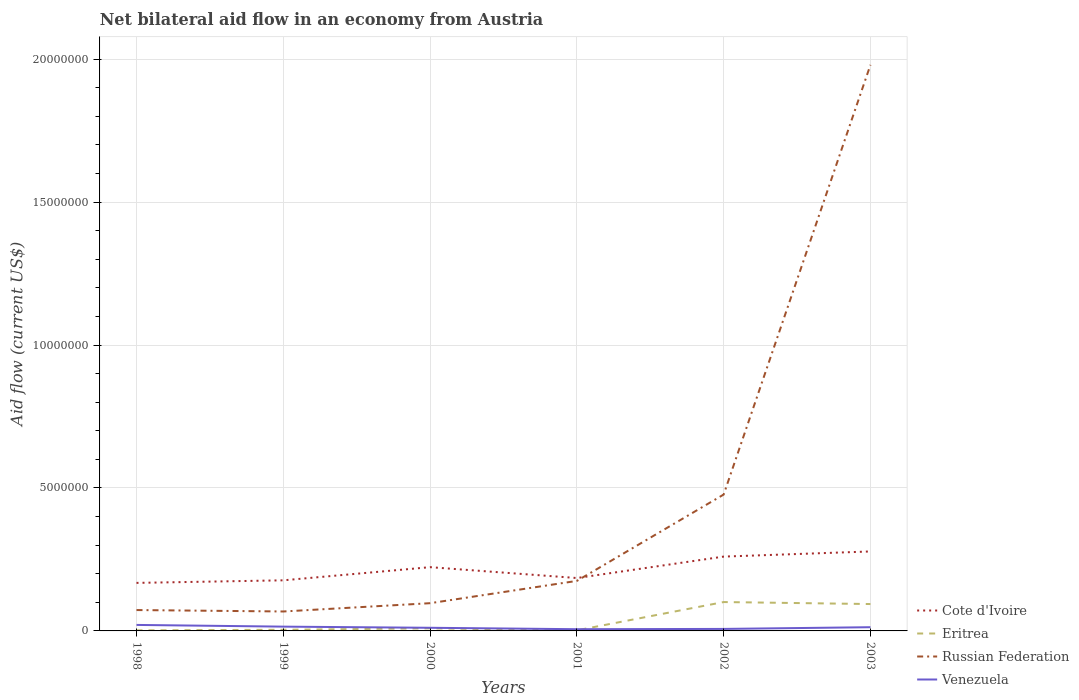How many different coloured lines are there?
Ensure brevity in your answer.  4. Does the line corresponding to Russian Federation intersect with the line corresponding to Cote d'Ivoire?
Your answer should be compact. Yes. Is the number of lines equal to the number of legend labels?
Your response must be concise. Yes. Across all years, what is the maximum net bilateral aid flow in Russian Federation?
Your answer should be very brief. 6.80e+05. In which year was the net bilateral aid flow in Cote d'Ivoire maximum?
Keep it short and to the point. 1998. What is the total net bilateral aid flow in Cote d'Ivoire in the graph?
Your answer should be compact. -8.00e+04. What is the difference between the highest and the second highest net bilateral aid flow in Eritrea?
Keep it short and to the point. 9.90e+05. What is the difference between the highest and the lowest net bilateral aid flow in Venezuela?
Offer a terse response. 3. How many lines are there?
Offer a very short reply. 4. How many years are there in the graph?
Provide a short and direct response. 6. Does the graph contain any zero values?
Offer a very short reply. No. Does the graph contain grids?
Provide a short and direct response. Yes. Where does the legend appear in the graph?
Your answer should be compact. Bottom right. How are the legend labels stacked?
Provide a succinct answer. Vertical. What is the title of the graph?
Offer a terse response. Net bilateral aid flow in an economy from Austria. Does "Norway" appear as one of the legend labels in the graph?
Keep it short and to the point. No. What is the Aid flow (current US$) in Cote d'Ivoire in 1998?
Give a very brief answer. 1.68e+06. What is the Aid flow (current US$) in Eritrea in 1998?
Provide a succinct answer. 2.00e+04. What is the Aid flow (current US$) in Russian Federation in 1998?
Your answer should be very brief. 7.30e+05. What is the Aid flow (current US$) in Venezuela in 1998?
Offer a terse response. 2.10e+05. What is the Aid flow (current US$) in Cote d'Ivoire in 1999?
Offer a very short reply. 1.77e+06. What is the Aid flow (current US$) in Eritrea in 1999?
Your response must be concise. 4.00e+04. What is the Aid flow (current US$) of Russian Federation in 1999?
Give a very brief answer. 6.80e+05. What is the Aid flow (current US$) of Venezuela in 1999?
Keep it short and to the point. 1.50e+05. What is the Aid flow (current US$) of Cote d'Ivoire in 2000?
Give a very brief answer. 2.23e+06. What is the Aid flow (current US$) of Russian Federation in 2000?
Provide a succinct answer. 9.70e+05. What is the Aid flow (current US$) in Venezuela in 2000?
Provide a succinct answer. 1.10e+05. What is the Aid flow (current US$) in Cote d'Ivoire in 2001?
Your response must be concise. 1.85e+06. What is the Aid flow (current US$) of Russian Federation in 2001?
Provide a short and direct response. 1.75e+06. What is the Aid flow (current US$) of Venezuela in 2001?
Keep it short and to the point. 6.00e+04. What is the Aid flow (current US$) in Cote d'Ivoire in 2002?
Make the answer very short. 2.60e+06. What is the Aid flow (current US$) in Eritrea in 2002?
Provide a short and direct response. 1.01e+06. What is the Aid flow (current US$) of Russian Federation in 2002?
Your response must be concise. 4.77e+06. What is the Aid flow (current US$) of Venezuela in 2002?
Offer a very short reply. 7.00e+04. What is the Aid flow (current US$) of Cote d'Ivoire in 2003?
Give a very brief answer. 2.78e+06. What is the Aid flow (current US$) of Eritrea in 2003?
Make the answer very short. 9.40e+05. What is the Aid flow (current US$) of Russian Federation in 2003?
Offer a terse response. 1.98e+07. Across all years, what is the maximum Aid flow (current US$) of Cote d'Ivoire?
Offer a very short reply. 2.78e+06. Across all years, what is the maximum Aid flow (current US$) in Eritrea?
Offer a terse response. 1.01e+06. Across all years, what is the maximum Aid flow (current US$) of Russian Federation?
Offer a very short reply. 1.98e+07. Across all years, what is the minimum Aid flow (current US$) in Cote d'Ivoire?
Ensure brevity in your answer.  1.68e+06. Across all years, what is the minimum Aid flow (current US$) of Russian Federation?
Your answer should be compact. 6.80e+05. Across all years, what is the minimum Aid flow (current US$) in Venezuela?
Provide a succinct answer. 6.00e+04. What is the total Aid flow (current US$) of Cote d'Ivoire in the graph?
Keep it short and to the point. 1.29e+07. What is the total Aid flow (current US$) in Eritrea in the graph?
Make the answer very short. 2.12e+06. What is the total Aid flow (current US$) in Russian Federation in the graph?
Offer a terse response. 2.87e+07. What is the total Aid flow (current US$) in Venezuela in the graph?
Your answer should be compact. 7.30e+05. What is the difference between the Aid flow (current US$) in Eritrea in 1998 and that in 1999?
Give a very brief answer. -2.00e+04. What is the difference between the Aid flow (current US$) in Russian Federation in 1998 and that in 1999?
Your answer should be compact. 5.00e+04. What is the difference between the Aid flow (current US$) in Venezuela in 1998 and that in 1999?
Your answer should be compact. 6.00e+04. What is the difference between the Aid flow (current US$) in Cote d'Ivoire in 1998 and that in 2000?
Keep it short and to the point. -5.50e+05. What is the difference between the Aid flow (current US$) in Cote d'Ivoire in 1998 and that in 2001?
Provide a short and direct response. -1.70e+05. What is the difference between the Aid flow (current US$) of Russian Federation in 1998 and that in 2001?
Your response must be concise. -1.02e+06. What is the difference between the Aid flow (current US$) in Venezuela in 1998 and that in 2001?
Offer a terse response. 1.50e+05. What is the difference between the Aid flow (current US$) of Cote d'Ivoire in 1998 and that in 2002?
Make the answer very short. -9.20e+05. What is the difference between the Aid flow (current US$) of Eritrea in 1998 and that in 2002?
Give a very brief answer. -9.90e+05. What is the difference between the Aid flow (current US$) of Russian Federation in 1998 and that in 2002?
Give a very brief answer. -4.04e+06. What is the difference between the Aid flow (current US$) of Venezuela in 1998 and that in 2002?
Your answer should be very brief. 1.40e+05. What is the difference between the Aid flow (current US$) of Cote d'Ivoire in 1998 and that in 2003?
Provide a short and direct response. -1.10e+06. What is the difference between the Aid flow (current US$) of Eritrea in 1998 and that in 2003?
Keep it short and to the point. -9.20e+05. What is the difference between the Aid flow (current US$) of Russian Federation in 1998 and that in 2003?
Your response must be concise. -1.91e+07. What is the difference between the Aid flow (current US$) in Cote d'Ivoire in 1999 and that in 2000?
Provide a short and direct response. -4.60e+05. What is the difference between the Aid flow (current US$) of Russian Federation in 1999 and that in 2000?
Ensure brevity in your answer.  -2.90e+05. What is the difference between the Aid flow (current US$) of Venezuela in 1999 and that in 2000?
Provide a succinct answer. 4.00e+04. What is the difference between the Aid flow (current US$) of Cote d'Ivoire in 1999 and that in 2001?
Your answer should be compact. -8.00e+04. What is the difference between the Aid flow (current US$) of Eritrea in 1999 and that in 2001?
Ensure brevity in your answer.  2.00e+04. What is the difference between the Aid flow (current US$) of Russian Federation in 1999 and that in 2001?
Your answer should be compact. -1.07e+06. What is the difference between the Aid flow (current US$) in Venezuela in 1999 and that in 2001?
Your answer should be very brief. 9.00e+04. What is the difference between the Aid flow (current US$) of Cote d'Ivoire in 1999 and that in 2002?
Give a very brief answer. -8.30e+05. What is the difference between the Aid flow (current US$) in Eritrea in 1999 and that in 2002?
Make the answer very short. -9.70e+05. What is the difference between the Aid flow (current US$) in Russian Federation in 1999 and that in 2002?
Offer a terse response. -4.09e+06. What is the difference between the Aid flow (current US$) of Venezuela in 1999 and that in 2002?
Provide a succinct answer. 8.00e+04. What is the difference between the Aid flow (current US$) of Cote d'Ivoire in 1999 and that in 2003?
Your answer should be compact. -1.01e+06. What is the difference between the Aid flow (current US$) in Eritrea in 1999 and that in 2003?
Provide a short and direct response. -9.00e+05. What is the difference between the Aid flow (current US$) in Russian Federation in 1999 and that in 2003?
Your answer should be very brief. -1.91e+07. What is the difference between the Aid flow (current US$) of Eritrea in 2000 and that in 2001?
Make the answer very short. 7.00e+04. What is the difference between the Aid flow (current US$) in Russian Federation in 2000 and that in 2001?
Your answer should be compact. -7.80e+05. What is the difference between the Aid flow (current US$) of Venezuela in 2000 and that in 2001?
Your answer should be compact. 5.00e+04. What is the difference between the Aid flow (current US$) in Cote d'Ivoire in 2000 and that in 2002?
Keep it short and to the point. -3.70e+05. What is the difference between the Aid flow (current US$) of Eritrea in 2000 and that in 2002?
Offer a terse response. -9.20e+05. What is the difference between the Aid flow (current US$) in Russian Federation in 2000 and that in 2002?
Provide a short and direct response. -3.80e+06. What is the difference between the Aid flow (current US$) in Cote d'Ivoire in 2000 and that in 2003?
Offer a terse response. -5.50e+05. What is the difference between the Aid flow (current US$) in Eritrea in 2000 and that in 2003?
Keep it short and to the point. -8.50e+05. What is the difference between the Aid flow (current US$) in Russian Federation in 2000 and that in 2003?
Your response must be concise. -1.88e+07. What is the difference between the Aid flow (current US$) in Venezuela in 2000 and that in 2003?
Your answer should be very brief. -2.00e+04. What is the difference between the Aid flow (current US$) in Cote d'Ivoire in 2001 and that in 2002?
Your response must be concise. -7.50e+05. What is the difference between the Aid flow (current US$) of Eritrea in 2001 and that in 2002?
Provide a succinct answer. -9.90e+05. What is the difference between the Aid flow (current US$) in Russian Federation in 2001 and that in 2002?
Keep it short and to the point. -3.02e+06. What is the difference between the Aid flow (current US$) of Venezuela in 2001 and that in 2002?
Ensure brevity in your answer.  -10000. What is the difference between the Aid flow (current US$) in Cote d'Ivoire in 2001 and that in 2003?
Offer a very short reply. -9.30e+05. What is the difference between the Aid flow (current US$) of Eritrea in 2001 and that in 2003?
Make the answer very short. -9.20e+05. What is the difference between the Aid flow (current US$) of Russian Federation in 2001 and that in 2003?
Your response must be concise. -1.80e+07. What is the difference between the Aid flow (current US$) in Cote d'Ivoire in 2002 and that in 2003?
Your answer should be very brief. -1.80e+05. What is the difference between the Aid flow (current US$) of Eritrea in 2002 and that in 2003?
Give a very brief answer. 7.00e+04. What is the difference between the Aid flow (current US$) of Russian Federation in 2002 and that in 2003?
Your response must be concise. -1.50e+07. What is the difference between the Aid flow (current US$) of Cote d'Ivoire in 1998 and the Aid flow (current US$) of Eritrea in 1999?
Make the answer very short. 1.64e+06. What is the difference between the Aid flow (current US$) of Cote d'Ivoire in 1998 and the Aid flow (current US$) of Venezuela in 1999?
Your answer should be compact. 1.53e+06. What is the difference between the Aid flow (current US$) of Eritrea in 1998 and the Aid flow (current US$) of Russian Federation in 1999?
Provide a succinct answer. -6.60e+05. What is the difference between the Aid flow (current US$) of Eritrea in 1998 and the Aid flow (current US$) of Venezuela in 1999?
Your response must be concise. -1.30e+05. What is the difference between the Aid flow (current US$) in Russian Federation in 1998 and the Aid flow (current US$) in Venezuela in 1999?
Your answer should be compact. 5.80e+05. What is the difference between the Aid flow (current US$) in Cote d'Ivoire in 1998 and the Aid flow (current US$) in Eritrea in 2000?
Offer a terse response. 1.59e+06. What is the difference between the Aid flow (current US$) in Cote d'Ivoire in 1998 and the Aid flow (current US$) in Russian Federation in 2000?
Offer a very short reply. 7.10e+05. What is the difference between the Aid flow (current US$) in Cote d'Ivoire in 1998 and the Aid flow (current US$) in Venezuela in 2000?
Make the answer very short. 1.57e+06. What is the difference between the Aid flow (current US$) of Eritrea in 1998 and the Aid flow (current US$) of Russian Federation in 2000?
Provide a succinct answer. -9.50e+05. What is the difference between the Aid flow (current US$) of Eritrea in 1998 and the Aid flow (current US$) of Venezuela in 2000?
Your answer should be very brief. -9.00e+04. What is the difference between the Aid flow (current US$) in Russian Federation in 1998 and the Aid flow (current US$) in Venezuela in 2000?
Make the answer very short. 6.20e+05. What is the difference between the Aid flow (current US$) of Cote d'Ivoire in 1998 and the Aid flow (current US$) of Eritrea in 2001?
Provide a short and direct response. 1.66e+06. What is the difference between the Aid flow (current US$) of Cote d'Ivoire in 1998 and the Aid flow (current US$) of Russian Federation in 2001?
Provide a short and direct response. -7.00e+04. What is the difference between the Aid flow (current US$) in Cote d'Ivoire in 1998 and the Aid flow (current US$) in Venezuela in 2001?
Provide a succinct answer. 1.62e+06. What is the difference between the Aid flow (current US$) of Eritrea in 1998 and the Aid flow (current US$) of Russian Federation in 2001?
Your answer should be compact. -1.73e+06. What is the difference between the Aid flow (current US$) of Russian Federation in 1998 and the Aid flow (current US$) of Venezuela in 2001?
Provide a short and direct response. 6.70e+05. What is the difference between the Aid flow (current US$) in Cote d'Ivoire in 1998 and the Aid flow (current US$) in Eritrea in 2002?
Give a very brief answer. 6.70e+05. What is the difference between the Aid flow (current US$) of Cote d'Ivoire in 1998 and the Aid flow (current US$) of Russian Federation in 2002?
Offer a terse response. -3.09e+06. What is the difference between the Aid flow (current US$) in Cote d'Ivoire in 1998 and the Aid flow (current US$) in Venezuela in 2002?
Provide a succinct answer. 1.61e+06. What is the difference between the Aid flow (current US$) in Eritrea in 1998 and the Aid flow (current US$) in Russian Federation in 2002?
Keep it short and to the point. -4.75e+06. What is the difference between the Aid flow (current US$) in Eritrea in 1998 and the Aid flow (current US$) in Venezuela in 2002?
Your answer should be very brief. -5.00e+04. What is the difference between the Aid flow (current US$) in Cote d'Ivoire in 1998 and the Aid flow (current US$) in Eritrea in 2003?
Ensure brevity in your answer.  7.40e+05. What is the difference between the Aid flow (current US$) in Cote d'Ivoire in 1998 and the Aid flow (current US$) in Russian Federation in 2003?
Provide a succinct answer. -1.81e+07. What is the difference between the Aid flow (current US$) of Cote d'Ivoire in 1998 and the Aid flow (current US$) of Venezuela in 2003?
Your response must be concise. 1.55e+06. What is the difference between the Aid flow (current US$) in Eritrea in 1998 and the Aid flow (current US$) in Russian Federation in 2003?
Make the answer very short. -1.98e+07. What is the difference between the Aid flow (current US$) in Cote d'Ivoire in 1999 and the Aid flow (current US$) in Eritrea in 2000?
Keep it short and to the point. 1.68e+06. What is the difference between the Aid flow (current US$) of Cote d'Ivoire in 1999 and the Aid flow (current US$) of Russian Federation in 2000?
Keep it short and to the point. 8.00e+05. What is the difference between the Aid flow (current US$) of Cote d'Ivoire in 1999 and the Aid flow (current US$) of Venezuela in 2000?
Your answer should be very brief. 1.66e+06. What is the difference between the Aid flow (current US$) in Eritrea in 1999 and the Aid flow (current US$) in Russian Federation in 2000?
Your response must be concise. -9.30e+05. What is the difference between the Aid flow (current US$) of Russian Federation in 1999 and the Aid flow (current US$) of Venezuela in 2000?
Ensure brevity in your answer.  5.70e+05. What is the difference between the Aid flow (current US$) in Cote d'Ivoire in 1999 and the Aid flow (current US$) in Eritrea in 2001?
Your answer should be compact. 1.75e+06. What is the difference between the Aid flow (current US$) in Cote d'Ivoire in 1999 and the Aid flow (current US$) in Venezuela in 2001?
Provide a short and direct response. 1.71e+06. What is the difference between the Aid flow (current US$) in Eritrea in 1999 and the Aid flow (current US$) in Russian Federation in 2001?
Ensure brevity in your answer.  -1.71e+06. What is the difference between the Aid flow (current US$) in Russian Federation in 1999 and the Aid flow (current US$) in Venezuela in 2001?
Keep it short and to the point. 6.20e+05. What is the difference between the Aid flow (current US$) of Cote d'Ivoire in 1999 and the Aid flow (current US$) of Eritrea in 2002?
Your answer should be very brief. 7.60e+05. What is the difference between the Aid flow (current US$) in Cote d'Ivoire in 1999 and the Aid flow (current US$) in Venezuela in 2002?
Offer a terse response. 1.70e+06. What is the difference between the Aid flow (current US$) in Eritrea in 1999 and the Aid flow (current US$) in Russian Federation in 2002?
Your answer should be very brief. -4.73e+06. What is the difference between the Aid flow (current US$) of Cote d'Ivoire in 1999 and the Aid flow (current US$) of Eritrea in 2003?
Give a very brief answer. 8.30e+05. What is the difference between the Aid flow (current US$) in Cote d'Ivoire in 1999 and the Aid flow (current US$) in Russian Federation in 2003?
Your answer should be very brief. -1.80e+07. What is the difference between the Aid flow (current US$) of Cote d'Ivoire in 1999 and the Aid flow (current US$) of Venezuela in 2003?
Provide a short and direct response. 1.64e+06. What is the difference between the Aid flow (current US$) in Eritrea in 1999 and the Aid flow (current US$) in Russian Federation in 2003?
Keep it short and to the point. -1.98e+07. What is the difference between the Aid flow (current US$) of Eritrea in 1999 and the Aid flow (current US$) of Venezuela in 2003?
Ensure brevity in your answer.  -9.00e+04. What is the difference between the Aid flow (current US$) in Russian Federation in 1999 and the Aid flow (current US$) in Venezuela in 2003?
Keep it short and to the point. 5.50e+05. What is the difference between the Aid flow (current US$) of Cote d'Ivoire in 2000 and the Aid flow (current US$) of Eritrea in 2001?
Make the answer very short. 2.21e+06. What is the difference between the Aid flow (current US$) of Cote d'Ivoire in 2000 and the Aid flow (current US$) of Russian Federation in 2001?
Your response must be concise. 4.80e+05. What is the difference between the Aid flow (current US$) of Cote d'Ivoire in 2000 and the Aid flow (current US$) of Venezuela in 2001?
Give a very brief answer. 2.17e+06. What is the difference between the Aid flow (current US$) in Eritrea in 2000 and the Aid flow (current US$) in Russian Federation in 2001?
Your answer should be compact. -1.66e+06. What is the difference between the Aid flow (current US$) in Eritrea in 2000 and the Aid flow (current US$) in Venezuela in 2001?
Keep it short and to the point. 3.00e+04. What is the difference between the Aid flow (current US$) of Russian Federation in 2000 and the Aid flow (current US$) of Venezuela in 2001?
Your response must be concise. 9.10e+05. What is the difference between the Aid flow (current US$) in Cote d'Ivoire in 2000 and the Aid flow (current US$) in Eritrea in 2002?
Your answer should be very brief. 1.22e+06. What is the difference between the Aid flow (current US$) of Cote d'Ivoire in 2000 and the Aid flow (current US$) of Russian Federation in 2002?
Your answer should be very brief. -2.54e+06. What is the difference between the Aid flow (current US$) of Cote d'Ivoire in 2000 and the Aid flow (current US$) of Venezuela in 2002?
Offer a terse response. 2.16e+06. What is the difference between the Aid flow (current US$) of Eritrea in 2000 and the Aid flow (current US$) of Russian Federation in 2002?
Give a very brief answer. -4.68e+06. What is the difference between the Aid flow (current US$) of Russian Federation in 2000 and the Aid flow (current US$) of Venezuela in 2002?
Ensure brevity in your answer.  9.00e+05. What is the difference between the Aid flow (current US$) of Cote d'Ivoire in 2000 and the Aid flow (current US$) of Eritrea in 2003?
Give a very brief answer. 1.29e+06. What is the difference between the Aid flow (current US$) of Cote d'Ivoire in 2000 and the Aid flow (current US$) of Russian Federation in 2003?
Offer a terse response. -1.76e+07. What is the difference between the Aid flow (current US$) of Cote d'Ivoire in 2000 and the Aid flow (current US$) of Venezuela in 2003?
Your response must be concise. 2.10e+06. What is the difference between the Aid flow (current US$) of Eritrea in 2000 and the Aid flow (current US$) of Russian Federation in 2003?
Offer a very short reply. -1.97e+07. What is the difference between the Aid flow (current US$) in Eritrea in 2000 and the Aid flow (current US$) in Venezuela in 2003?
Provide a short and direct response. -4.00e+04. What is the difference between the Aid flow (current US$) in Russian Federation in 2000 and the Aid flow (current US$) in Venezuela in 2003?
Offer a very short reply. 8.40e+05. What is the difference between the Aid flow (current US$) of Cote d'Ivoire in 2001 and the Aid flow (current US$) of Eritrea in 2002?
Give a very brief answer. 8.40e+05. What is the difference between the Aid flow (current US$) in Cote d'Ivoire in 2001 and the Aid flow (current US$) in Russian Federation in 2002?
Your answer should be very brief. -2.92e+06. What is the difference between the Aid flow (current US$) of Cote d'Ivoire in 2001 and the Aid flow (current US$) of Venezuela in 2002?
Keep it short and to the point. 1.78e+06. What is the difference between the Aid flow (current US$) in Eritrea in 2001 and the Aid flow (current US$) in Russian Federation in 2002?
Offer a terse response. -4.75e+06. What is the difference between the Aid flow (current US$) of Eritrea in 2001 and the Aid flow (current US$) of Venezuela in 2002?
Your answer should be compact. -5.00e+04. What is the difference between the Aid flow (current US$) of Russian Federation in 2001 and the Aid flow (current US$) of Venezuela in 2002?
Your answer should be compact. 1.68e+06. What is the difference between the Aid flow (current US$) in Cote d'Ivoire in 2001 and the Aid flow (current US$) in Eritrea in 2003?
Your response must be concise. 9.10e+05. What is the difference between the Aid flow (current US$) in Cote d'Ivoire in 2001 and the Aid flow (current US$) in Russian Federation in 2003?
Make the answer very short. -1.80e+07. What is the difference between the Aid flow (current US$) of Cote d'Ivoire in 2001 and the Aid flow (current US$) of Venezuela in 2003?
Keep it short and to the point. 1.72e+06. What is the difference between the Aid flow (current US$) in Eritrea in 2001 and the Aid flow (current US$) in Russian Federation in 2003?
Provide a short and direct response. -1.98e+07. What is the difference between the Aid flow (current US$) of Eritrea in 2001 and the Aid flow (current US$) of Venezuela in 2003?
Keep it short and to the point. -1.10e+05. What is the difference between the Aid flow (current US$) of Russian Federation in 2001 and the Aid flow (current US$) of Venezuela in 2003?
Keep it short and to the point. 1.62e+06. What is the difference between the Aid flow (current US$) in Cote d'Ivoire in 2002 and the Aid flow (current US$) in Eritrea in 2003?
Keep it short and to the point. 1.66e+06. What is the difference between the Aid flow (current US$) of Cote d'Ivoire in 2002 and the Aid flow (current US$) of Russian Federation in 2003?
Your answer should be very brief. -1.72e+07. What is the difference between the Aid flow (current US$) in Cote d'Ivoire in 2002 and the Aid flow (current US$) in Venezuela in 2003?
Make the answer very short. 2.47e+06. What is the difference between the Aid flow (current US$) in Eritrea in 2002 and the Aid flow (current US$) in Russian Federation in 2003?
Make the answer very short. -1.88e+07. What is the difference between the Aid flow (current US$) in Eritrea in 2002 and the Aid flow (current US$) in Venezuela in 2003?
Offer a very short reply. 8.80e+05. What is the difference between the Aid flow (current US$) of Russian Federation in 2002 and the Aid flow (current US$) of Venezuela in 2003?
Ensure brevity in your answer.  4.64e+06. What is the average Aid flow (current US$) in Cote d'Ivoire per year?
Your response must be concise. 2.15e+06. What is the average Aid flow (current US$) in Eritrea per year?
Your response must be concise. 3.53e+05. What is the average Aid flow (current US$) in Russian Federation per year?
Give a very brief answer. 4.78e+06. What is the average Aid flow (current US$) in Venezuela per year?
Provide a succinct answer. 1.22e+05. In the year 1998, what is the difference between the Aid flow (current US$) in Cote d'Ivoire and Aid flow (current US$) in Eritrea?
Your response must be concise. 1.66e+06. In the year 1998, what is the difference between the Aid flow (current US$) of Cote d'Ivoire and Aid flow (current US$) of Russian Federation?
Keep it short and to the point. 9.50e+05. In the year 1998, what is the difference between the Aid flow (current US$) of Cote d'Ivoire and Aid flow (current US$) of Venezuela?
Your answer should be compact. 1.47e+06. In the year 1998, what is the difference between the Aid flow (current US$) in Eritrea and Aid flow (current US$) in Russian Federation?
Ensure brevity in your answer.  -7.10e+05. In the year 1998, what is the difference between the Aid flow (current US$) of Eritrea and Aid flow (current US$) of Venezuela?
Your response must be concise. -1.90e+05. In the year 1998, what is the difference between the Aid flow (current US$) of Russian Federation and Aid flow (current US$) of Venezuela?
Your response must be concise. 5.20e+05. In the year 1999, what is the difference between the Aid flow (current US$) of Cote d'Ivoire and Aid flow (current US$) of Eritrea?
Ensure brevity in your answer.  1.73e+06. In the year 1999, what is the difference between the Aid flow (current US$) in Cote d'Ivoire and Aid flow (current US$) in Russian Federation?
Provide a succinct answer. 1.09e+06. In the year 1999, what is the difference between the Aid flow (current US$) in Cote d'Ivoire and Aid flow (current US$) in Venezuela?
Your response must be concise. 1.62e+06. In the year 1999, what is the difference between the Aid flow (current US$) of Eritrea and Aid flow (current US$) of Russian Federation?
Your response must be concise. -6.40e+05. In the year 1999, what is the difference between the Aid flow (current US$) of Russian Federation and Aid flow (current US$) of Venezuela?
Offer a terse response. 5.30e+05. In the year 2000, what is the difference between the Aid flow (current US$) in Cote d'Ivoire and Aid flow (current US$) in Eritrea?
Keep it short and to the point. 2.14e+06. In the year 2000, what is the difference between the Aid flow (current US$) in Cote d'Ivoire and Aid flow (current US$) in Russian Federation?
Offer a very short reply. 1.26e+06. In the year 2000, what is the difference between the Aid flow (current US$) in Cote d'Ivoire and Aid flow (current US$) in Venezuela?
Give a very brief answer. 2.12e+06. In the year 2000, what is the difference between the Aid flow (current US$) in Eritrea and Aid flow (current US$) in Russian Federation?
Keep it short and to the point. -8.80e+05. In the year 2000, what is the difference between the Aid flow (current US$) in Eritrea and Aid flow (current US$) in Venezuela?
Give a very brief answer. -2.00e+04. In the year 2000, what is the difference between the Aid flow (current US$) of Russian Federation and Aid flow (current US$) of Venezuela?
Your answer should be compact. 8.60e+05. In the year 2001, what is the difference between the Aid flow (current US$) in Cote d'Ivoire and Aid flow (current US$) in Eritrea?
Offer a very short reply. 1.83e+06. In the year 2001, what is the difference between the Aid flow (current US$) in Cote d'Ivoire and Aid flow (current US$) in Russian Federation?
Your answer should be very brief. 1.00e+05. In the year 2001, what is the difference between the Aid flow (current US$) of Cote d'Ivoire and Aid flow (current US$) of Venezuela?
Offer a terse response. 1.79e+06. In the year 2001, what is the difference between the Aid flow (current US$) in Eritrea and Aid flow (current US$) in Russian Federation?
Ensure brevity in your answer.  -1.73e+06. In the year 2001, what is the difference between the Aid flow (current US$) of Eritrea and Aid flow (current US$) of Venezuela?
Keep it short and to the point. -4.00e+04. In the year 2001, what is the difference between the Aid flow (current US$) of Russian Federation and Aid flow (current US$) of Venezuela?
Provide a succinct answer. 1.69e+06. In the year 2002, what is the difference between the Aid flow (current US$) in Cote d'Ivoire and Aid flow (current US$) in Eritrea?
Your response must be concise. 1.59e+06. In the year 2002, what is the difference between the Aid flow (current US$) in Cote d'Ivoire and Aid flow (current US$) in Russian Federation?
Ensure brevity in your answer.  -2.17e+06. In the year 2002, what is the difference between the Aid flow (current US$) in Cote d'Ivoire and Aid flow (current US$) in Venezuela?
Offer a very short reply. 2.53e+06. In the year 2002, what is the difference between the Aid flow (current US$) of Eritrea and Aid flow (current US$) of Russian Federation?
Provide a short and direct response. -3.76e+06. In the year 2002, what is the difference between the Aid flow (current US$) of Eritrea and Aid flow (current US$) of Venezuela?
Make the answer very short. 9.40e+05. In the year 2002, what is the difference between the Aid flow (current US$) of Russian Federation and Aid flow (current US$) of Venezuela?
Make the answer very short. 4.70e+06. In the year 2003, what is the difference between the Aid flow (current US$) in Cote d'Ivoire and Aid flow (current US$) in Eritrea?
Your answer should be very brief. 1.84e+06. In the year 2003, what is the difference between the Aid flow (current US$) in Cote d'Ivoire and Aid flow (current US$) in Russian Federation?
Provide a succinct answer. -1.70e+07. In the year 2003, what is the difference between the Aid flow (current US$) in Cote d'Ivoire and Aid flow (current US$) in Venezuela?
Give a very brief answer. 2.65e+06. In the year 2003, what is the difference between the Aid flow (current US$) in Eritrea and Aid flow (current US$) in Russian Federation?
Provide a short and direct response. -1.89e+07. In the year 2003, what is the difference between the Aid flow (current US$) of Eritrea and Aid flow (current US$) of Venezuela?
Your answer should be very brief. 8.10e+05. In the year 2003, what is the difference between the Aid flow (current US$) of Russian Federation and Aid flow (current US$) of Venezuela?
Provide a short and direct response. 1.97e+07. What is the ratio of the Aid flow (current US$) in Cote d'Ivoire in 1998 to that in 1999?
Ensure brevity in your answer.  0.95. What is the ratio of the Aid flow (current US$) in Eritrea in 1998 to that in 1999?
Give a very brief answer. 0.5. What is the ratio of the Aid flow (current US$) of Russian Federation in 1998 to that in 1999?
Make the answer very short. 1.07. What is the ratio of the Aid flow (current US$) in Cote d'Ivoire in 1998 to that in 2000?
Provide a succinct answer. 0.75. What is the ratio of the Aid flow (current US$) of Eritrea in 1998 to that in 2000?
Provide a succinct answer. 0.22. What is the ratio of the Aid flow (current US$) in Russian Federation in 1998 to that in 2000?
Ensure brevity in your answer.  0.75. What is the ratio of the Aid flow (current US$) in Venezuela in 1998 to that in 2000?
Your answer should be very brief. 1.91. What is the ratio of the Aid flow (current US$) of Cote d'Ivoire in 1998 to that in 2001?
Give a very brief answer. 0.91. What is the ratio of the Aid flow (current US$) of Russian Federation in 1998 to that in 2001?
Offer a terse response. 0.42. What is the ratio of the Aid flow (current US$) of Cote d'Ivoire in 1998 to that in 2002?
Offer a very short reply. 0.65. What is the ratio of the Aid flow (current US$) of Eritrea in 1998 to that in 2002?
Your response must be concise. 0.02. What is the ratio of the Aid flow (current US$) in Russian Federation in 1998 to that in 2002?
Keep it short and to the point. 0.15. What is the ratio of the Aid flow (current US$) in Cote d'Ivoire in 1998 to that in 2003?
Provide a succinct answer. 0.6. What is the ratio of the Aid flow (current US$) of Eritrea in 1998 to that in 2003?
Keep it short and to the point. 0.02. What is the ratio of the Aid flow (current US$) in Russian Federation in 1998 to that in 2003?
Keep it short and to the point. 0.04. What is the ratio of the Aid flow (current US$) in Venezuela in 1998 to that in 2003?
Your response must be concise. 1.62. What is the ratio of the Aid flow (current US$) of Cote d'Ivoire in 1999 to that in 2000?
Your response must be concise. 0.79. What is the ratio of the Aid flow (current US$) in Eritrea in 1999 to that in 2000?
Offer a very short reply. 0.44. What is the ratio of the Aid flow (current US$) in Russian Federation in 1999 to that in 2000?
Your answer should be compact. 0.7. What is the ratio of the Aid flow (current US$) of Venezuela in 1999 to that in 2000?
Ensure brevity in your answer.  1.36. What is the ratio of the Aid flow (current US$) in Cote d'Ivoire in 1999 to that in 2001?
Keep it short and to the point. 0.96. What is the ratio of the Aid flow (current US$) of Eritrea in 1999 to that in 2001?
Your answer should be very brief. 2. What is the ratio of the Aid flow (current US$) of Russian Federation in 1999 to that in 2001?
Provide a short and direct response. 0.39. What is the ratio of the Aid flow (current US$) in Cote d'Ivoire in 1999 to that in 2002?
Offer a terse response. 0.68. What is the ratio of the Aid flow (current US$) in Eritrea in 1999 to that in 2002?
Offer a very short reply. 0.04. What is the ratio of the Aid flow (current US$) of Russian Federation in 1999 to that in 2002?
Your answer should be very brief. 0.14. What is the ratio of the Aid flow (current US$) of Venezuela in 1999 to that in 2002?
Offer a terse response. 2.14. What is the ratio of the Aid flow (current US$) in Cote d'Ivoire in 1999 to that in 2003?
Make the answer very short. 0.64. What is the ratio of the Aid flow (current US$) of Eritrea in 1999 to that in 2003?
Offer a very short reply. 0.04. What is the ratio of the Aid flow (current US$) in Russian Federation in 1999 to that in 2003?
Your answer should be very brief. 0.03. What is the ratio of the Aid flow (current US$) in Venezuela in 1999 to that in 2003?
Offer a terse response. 1.15. What is the ratio of the Aid flow (current US$) in Cote d'Ivoire in 2000 to that in 2001?
Provide a short and direct response. 1.21. What is the ratio of the Aid flow (current US$) in Russian Federation in 2000 to that in 2001?
Make the answer very short. 0.55. What is the ratio of the Aid flow (current US$) in Venezuela in 2000 to that in 2001?
Provide a short and direct response. 1.83. What is the ratio of the Aid flow (current US$) in Cote d'Ivoire in 2000 to that in 2002?
Offer a terse response. 0.86. What is the ratio of the Aid flow (current US$) in Eritrea in 2000 to that in 2002?
Offer a very short reply. 0.09. What is the ratio of the Aid flow (current US$) of Russian Federation in 2000 to that in 2002?
Your response must be concise. 0.2. What is the ratio of the Aid flow (current US$) in Venezuela in 2000 to that in 2002?
Offer a terse response. 1.57. What is the ratio of the Aid flow (current US$) of Cote d'Ivoire in 2000 to that in 2003?
Give a very brief answer. 0.8. What is the ratio of the Aid flow (current US$) of Eritrea in 2000 to that in 2003?
Provide a succinct answer. 0.1. What is the ratio of the Aid flow (current US$) of Russian Federation in 2000 to that in 2003?
Provide a succinct answer. 0.05. What is the ratio of the Aid flow (current US$) in Venezuela in 2000 to that in 2003?
Provide a short and direct response. 0.85. What is the ratio of the Aid flow (current US$) of Cote d'Ivoire in 2001 to that in 2002?
Keep it short and to the point. 0.71. What is the ratio of the Aid flow (current US$) in Eritrea in 2001 to that in 2002?
Offer a very short reply. 0.02. What is the ratio of the Aid flow (current US$) in Russian Federation in 2001 to that in 2002?
Ensure brevity in your answer.  0.37. What is the ratio of the Aid flow (current US$) of Venezuela in 2001 to that in 2002?
Keep it short and to the point. 0.86. What is the ratio of the Aid flow (current US$) of Cote d'Ivoire in 2001 to that in 2003?
Your answer should be compact. 0.67. What is the ratio of the Aid flow (current US$) in Eritrea in 2001 to that in 2003?
Give a very brief answer. 0.02. What is the ratio of the Aid flow (current US$) of Russian Federation in 2001 to that in 2003?
Give a very brief answer. 0.09. What is the ratio of the Aid flow (current US$) of Venezuela in 2001 to that in 2003?
Your answer should be compact. 0.46. What is the ratio of the Aid flow (current US$) in Cote d'Ivoire in 2002 to that in 2003?
Give a very brief answer. 0.94. What is the ratio of the Aid flow (current US$) in Eritrea in 2002 to that in 2003?
Your answer should be very brief. 1.07. What is the ratio of the Aid flow (current US$) in Russian Federation in 2002 to that in 2003?
Provide a short and direct response. 0.24. What is the ratio of the Aid flow (current US$) of Venezuela in 2002 to that in 2003?
Keep it short and to the point. 0.54. What is the difference between the highest and the second highest Aid flow (current US$) of Russian Federation?
Provide a short and direct response. 1.50e+07. What is the difference between the highest and the lowest Aid flow (current US$) of Cote d'Ivoire?
Keep it short and to the point. 1.10e+06. What is the difference between the highest and the lowest Aid flow (current US$) in Eritrea?
Offer a terse response. 9.90e+05. What is the difference between the highest and the lowest Aid flow (current US$) of Russian Federation?
Keep it short and to the point. 1.91e+07. What is the difference between the highest and the lowest Aid flow (current US$) of Venezuela?
Provide a short and direct response. 1.50e+05. 